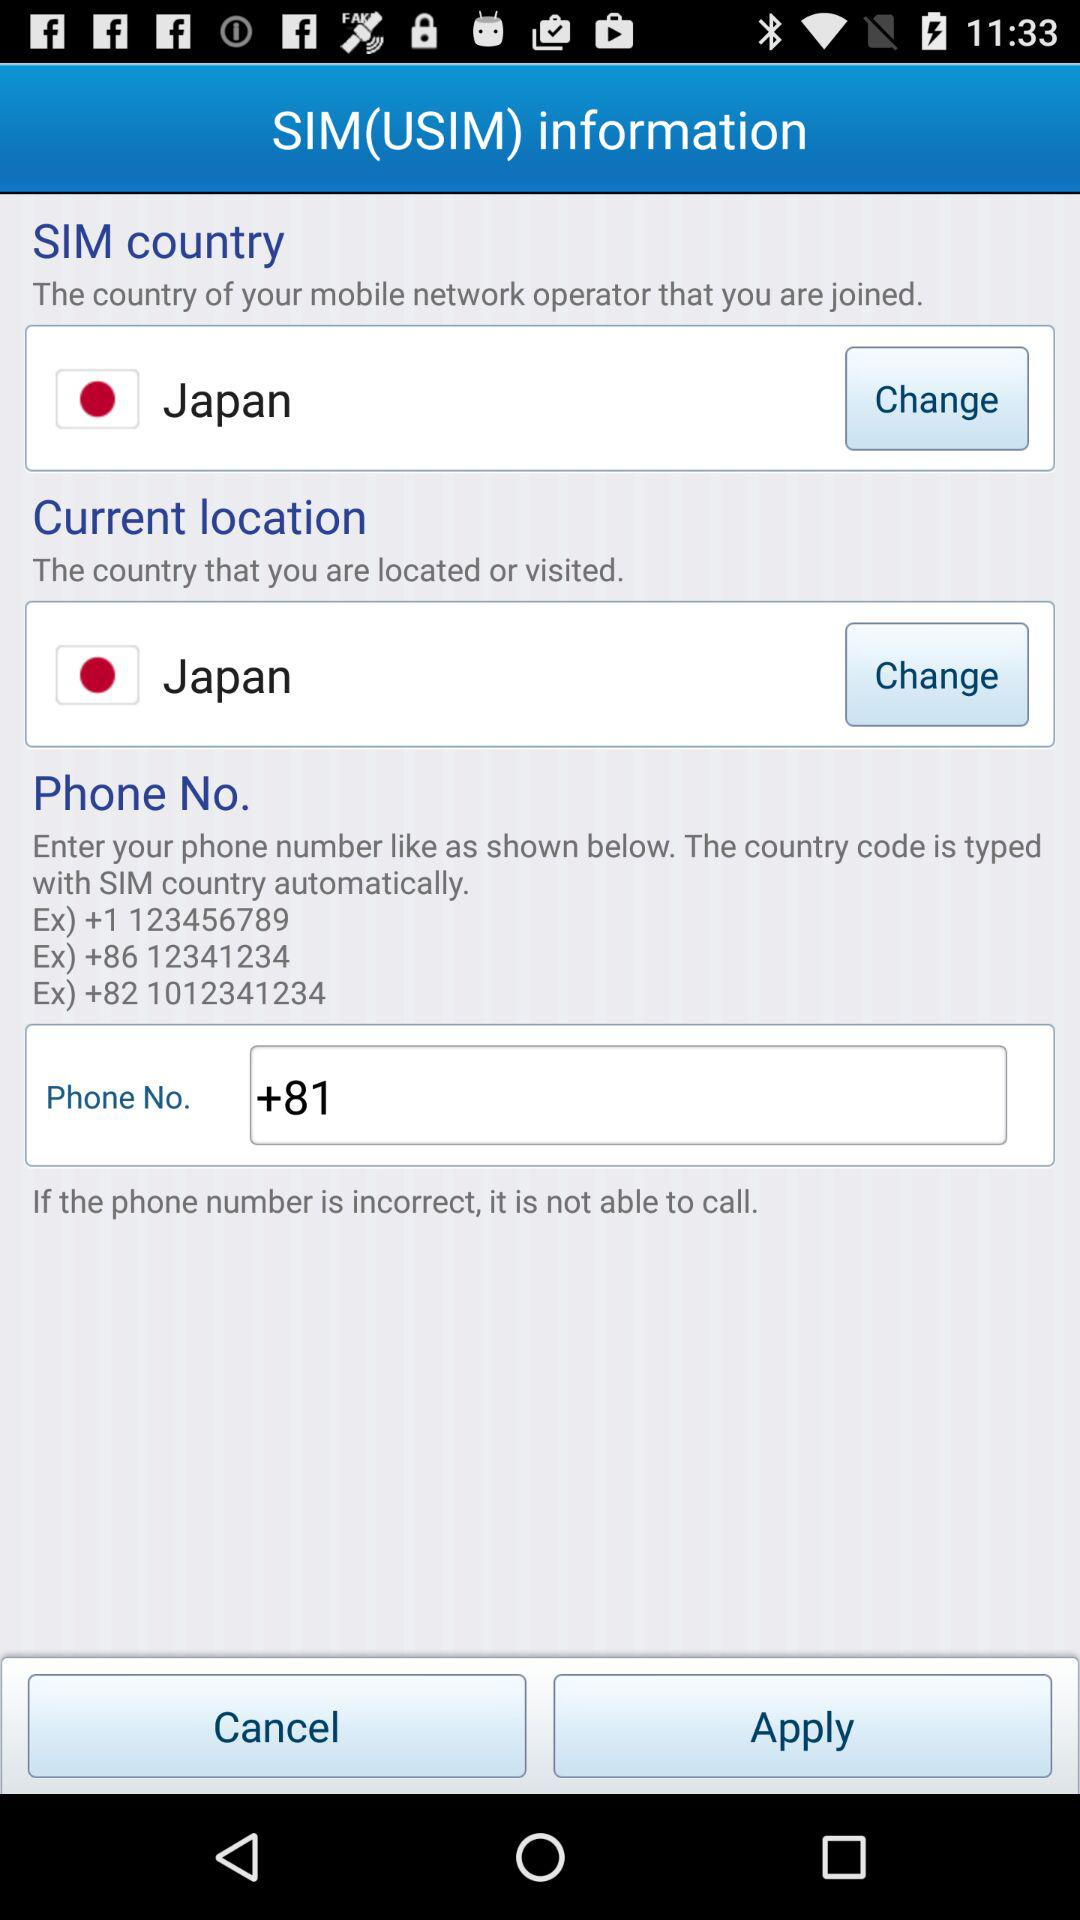What is the phone number starting with the country code +1? The phone number is 123456789. 